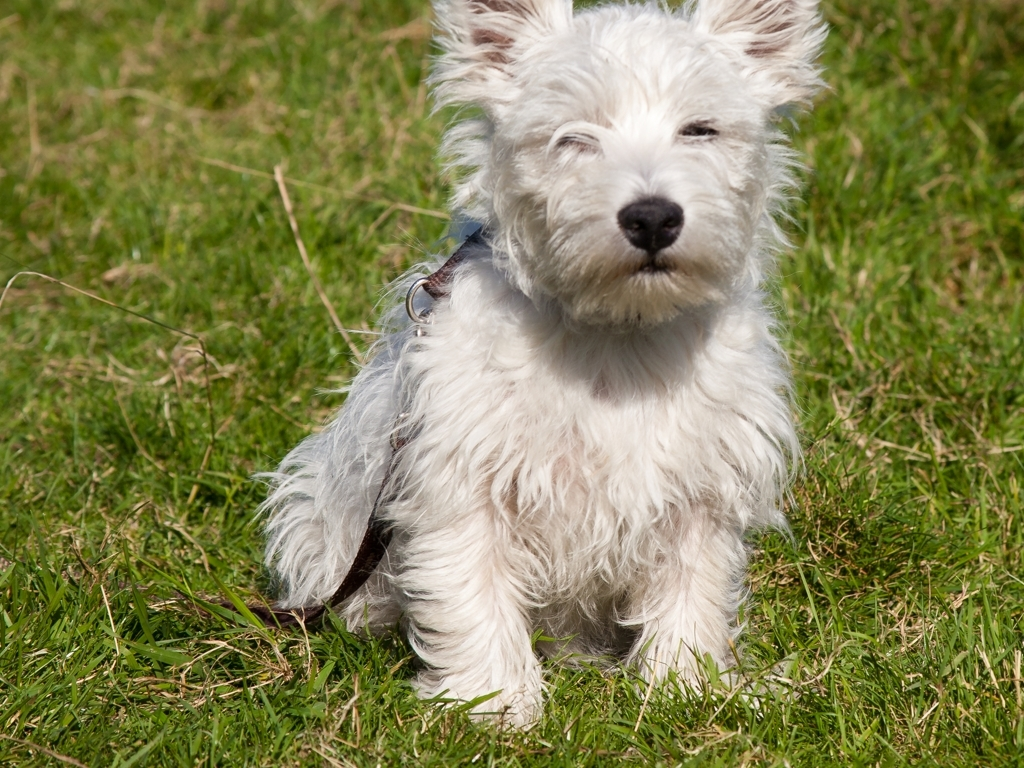What are the characteristics of the image's colors? The image presents a palette that could be best described as vibrant due to the bright and lively green of the grass, which contrasts effectively with the dog's white fur. The sunlight enhances the brightness of the colors, adding a sense of vitality and warmth to the picture. 